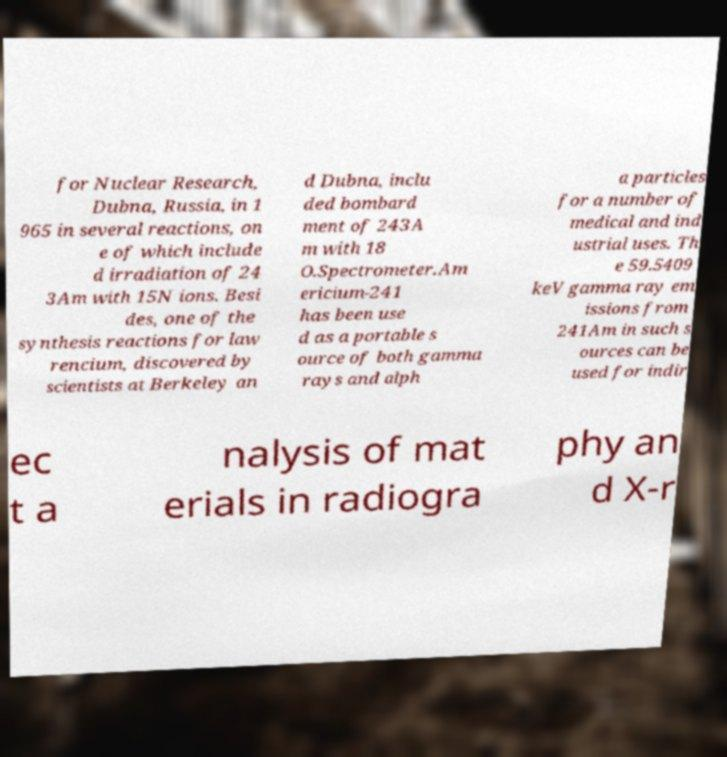Could you assist in decoding the text presented in this image and type it out clearly? for Nuclear Research, Dubna, Russia, in 1 965 in several reactions, on e of which include d irradiation of 24 3Am with 15N ions. Besi des, one of the synthesis reactions for law rencium, discovered by scientists at Berkeley an d Dubna, inclu ded bombard ment of 243A m with 18 O.Spectrometer.Am ericium-241 has been use d as a portable s ource of both gamma rays and alph a particles for a number of medical and ind ustrial uses. Th e 59.5409 keV gamma ray em issions from 241Am in such s ources can be used for indir ec t a nalysis of mat erials in radiogra phy an d X-r 